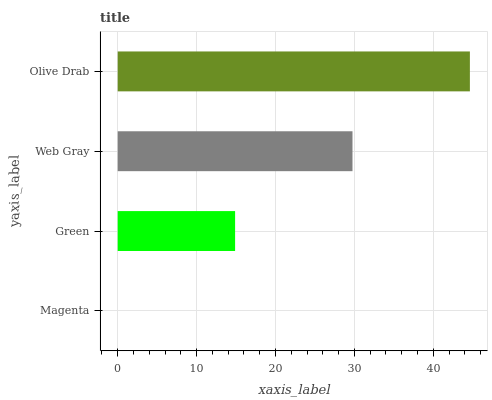Is Magenta the minimum?
Answer yes or no. Yes. Is Olive Drab the maximum?
Answer yes or no. Yes. Is Green the minimum?
Answer yes or no. No. Is Green the maximum?
Answer yes or no. No. Is Green greater than Magenta?
Answer yes or no. Yes. Is Magenta less than Green?
Answer yes or no. Yes. Is Magenta greater than Green?
Answer yes or no. No. Is Green less than Magenta?
Answer yes or no. No. Is Web Gray the high median?
Answer yes or no. Yes. Is Green the low median?
Answer yes or no. Yes. Is Olive Drab the high median?
Answer yes or no. No. Is Web Gray the low median?
Answer yes or no. No. 